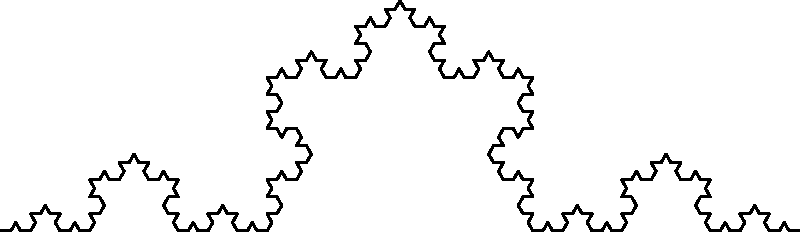In a techno music visualization software, you've noticed that the waveform display occasionally forms a pattern similar to the Koch snowflake fractal. If the initial line segment has a length of 243 units, what would be the total length of the curve after 5 iterations of the Koch snowflake algorithm? To solve this problem, let's follow these steps:

1. Recall the Koch snowflake algorithm:
   - Divide the line segment into three equal parts
   - Replace the middle part with two sides of an equilateral triangle

2. Understand how the length changes with each iteration:
   - Each segment is replaced by four segments, each 1/3 of the original length
   - This means the length increases by a factor of 4/3 in each iteration

3. Calculate the length after 5 iterations:
   - Initial length: $L_0 = 243$ units
   - After 1st iteration: $L_1 = L_0 \times \frac{4}{3} = 243 \times \frac{4}{3}$
   - After 2nd iteration: $L_2 = L_1 \times \frac{4}{3} = 243 \times (\frac{4}{3})^2$
   - ...
   - After 5th iteration: $L_5 = 243 \times (\frac{4}{3})^5$

4. Compute the final result:
   $L_5 = 243 \times (\frac{4}{3})^5 = 243 \times \frac{1024}{243} = 1024$ units

Therefore, after 5 iterations, the total length of the curve will be 1024 units.
Answer: 1024 units 